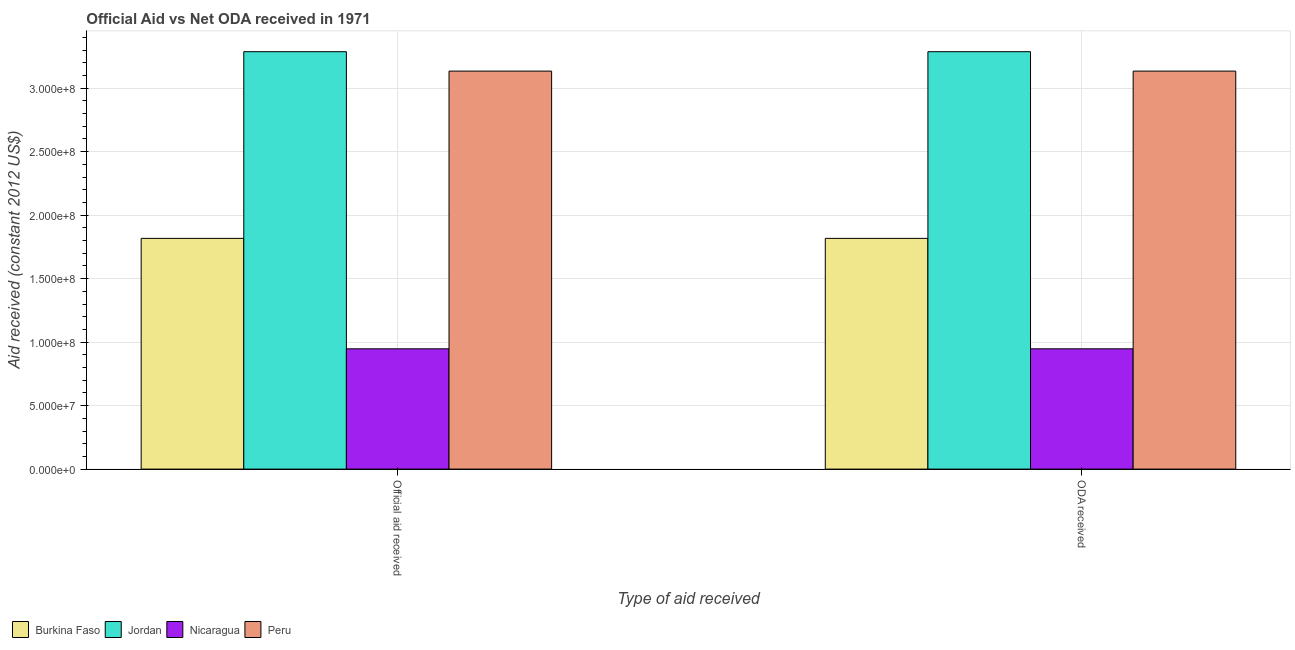How many bars are there on the 1st tick from the left?
Offer a terse response. 4. How many bars are there on the 2nd tick from the right?
Your answer should be very brief. 4. What is the label of the 2nd group of bars from the left?
Ensure brevity in your answer.  ODA received. What is the oda received in Jordan?
Give a very brief answer. 3.29e+08. Across all countries, what is the maximum oda received?
Your response must be concise. 3.29e+08. Across all countries, what is the minimum oda received?
Make the answer very short. 9.47e+07. In which country was the official aid received maximum?
Offer a terse response. Jordan. In which country was the official aid received minimum?
Keep it short and to the point. Nicaragua. What is the total oda received in the graph?
Ensure brevity in your answer.  9.19e+08. What is the difference between the official aid received in Burkina Faso and that in Nicaragua?
Give a very brief answer. 8.70e+07. What is the difference between the oda received in Burkina Faso and the official aid received in Nicaragua?
Make the answer very short. 8.70e+07. What is the average official aid received per country?
Your answer should be very brief. 2.30e+08. What is the difference between the oda received and official aid received in Jordan?
Provide a short and direct response. 0. What is the ratio of the official aid received in Peru to that in Jordan?
Your response must be concise. 0.95. In how many countries, is the oda received greater than the average oda received taken over all countries?
Provide a short and direct response. 2. What does the 2nd bar from the left in ODA received represents?
Provide a succinct answer. Jordan. What does the 3rd bar from the right in ODA received represents?
Ensure brevity in your answer.  Jordan. How many countries are there in the graph?
Ensure brevity in your answer.  4. Are the values on the major ticks of Y-axis written in scientific E-notation?
Offer a very short reply. Yes. Where does the legend appear in the graph?
Keep it short and to the point. Bottom left. How are the legend labels stacked?
Provide a short and direct response. Horizontal. What is the title of the graph?
Give a very brief answer. Official Aid vs Net ODA received in 1971 . Does "Latin America(developing only)" appear as one of the legend labels in the graph?
Ensure brevity in your answer.  No. What is the label or title of the X-axis?
Keep it short and to the point. Type of aid received. What is the label or title of the Y-axis?
Your answer should be compact. Aid received (constant 2012 US$). What is the Aid received (constant 2012 US$) of Burkina Faso in Official aid received?
Offer a terse response. 1.82e+08. What is the Aid received (constant 2012 US$) of Jordan in Official aid received?
Provide a short and direct response. 3.29e+08. What is the Aid received (constant 2012 US$) in Nicaragua in Official aid received?
Offer a terse response. 9.47e+07. What is the Aid received (constant 2012 US$) of Peru in Official aid received?
Your answer should be compact. 3.13e+08. What is the Aid received (constant 2012 US$) in Burkina Faso in ODA received?
Provide a succinct answer. 1.82e+08. What is the Aid received (constant 2012 US$) of Jordan in ODA received?
Make the answer very short. 3.29e+08. What is the Aid received (constant 2012 US$) of Nicaragua in ODA received?
Your answer should be very brief. 9.47e+07. What is the Aid received (constant 2012 US$) of Peru in ODA received?
Ensure brevity in your answer.  3.13e+08. Across all Type of aid received, what is the maximum Aid received (constant 2012 US$) of Burkina Faso?
Offer a very short reply. 1.82e+08. Across all Type of aid received, what is the maximum Aid received (constant 2012 US$) in Jordan?
Your response must be concise. 3.29e+08. Across all Type of aid received, what is the maximum Aid received (constant 2012 US$) of Nicaragua?
Give a very brief answer. 9.47e+07. Across all Type of aid received, what is the maximum Aid received (constant 2012 US$) in Peru?
Provide a succinct answer. 3.13e+08. Across all Type of aid received, what is the minimum Aid received (constant 2012 US$) in Burkina Faso?
Offer a very short reply. 1.82e+08. Across all Type of aid received, what is the minimum Aid received (constant 2012 US$) in Jordan?
Offer a very short reply. 3.29e+08. Across all Type of aid received, what is the minimum Aid received (constant 2012 US$) of Nicaragua?
Offer a terse response. 9.47e+07. Across all Type of aid received, what is the minimum Aid received (constant 2012 US$) of Peru?
Give a very brief answer. 3.13e+08. What is the total Aid received (constant 2012 US$) in Burkina Faso in the graph?
Your answer should be very brief. 3.63e+08. What is the total Aid received (constant 2012 US$) in Jordan in the graph?
Your answer should be very brief. 6.57e+08. What is the total Aid received (constant 2012 US$) in Nicaragua in the graph?
Your answer should be very brief. 1.89e+08. What is the total Aid received (constant 2012 US$) in Peru in the graph?
Offer a very short reply. 6.27e+08. What is the difference between the Aid received (constant 2012 US$) of Jordan in Official aid received and that in ODA received?
Keep it short and to the point. 0. What is the difference between the Aid received (constant 2012 US$) of Peru in Official aid received and that in ODA received?
Offer a very short reply. 0. What is the difference between the Aid received (constant 2012 US$) in Burkina Faso in Official aid received and the Aid received (constant 2012 US$) in Jordan in ODA received?
Offer a very short reply. -1.47e+08. What is the difference between the Aid received (constant 2012 US$) of Burkina Faso in Official aid received and the Aid received (constant 2012 US$) of Nicaragua in ODA received?
Your answer should be very brief. 8.70e+07. What is the difference between the Aid received (constant 2012 US$) of Burkina Faso in Official aid received and the Aid received (constant 2012 US$) of Peru in ODA received?
Offer a very short reply. -1.32e+08. What is the difference between the Aid received (constant 2012 US$) of Jordan in Official aid received and the Aid received (constant 2012 US$) of Nicaragua in ODA received?
Your answer should be compact. 2.34e+08. What is the difference between the Aid received (constant 2012 US$) of Jordan in Official aid received and the Aid received (constant 2012 US$) of Peru in ODA received?
Make the answer very short. 1.53e+07. What is the difference between the Aid received (constant 2012 US$) of Nicaragua in Official aid received and the Aid received (constant 2012 US$) of Peru in ODA received?
Provide a succinct answer. -2.19e+08. What is the average Aid received (constant 2012 US$) in Burkina Faso per Type of aid received?
Offer a terse response. 1.82e+08. What is the average Aid received (constant 2012 US$) of Jordan per Type of aid received?
Give a very brief answer. 3.29e+08. What is the average Aid received (constant 2012 US$) in Nicaragua per Type of aid received?
Provide a succinct answer. 9.47e+07. What is the average Aid received (constant 2012 US$) in Peru per Type of aid received?
Ensure brevity in your answer.  3.13e+08. What is the difference between the Aid received (constant 2012 US$) of Burkina Faso and Aid received (constant 2012 US$) of Jordan in Official aid received?
Provide a short and direct response. -1.47e+08. What is the difference between the Aid received (constant 2012 US$) of Burkina Faso and Aid received (constant 2012 US$) of Nicaragua in Official aid received?
Ensure brevity in your answer.  8.70e+07. What is the difference between the Aid received (constant 2012 US$) of Burkina Faso and Aid received (constant 2012 US$) of Peru in Official aid received?
Offer a terse response. -1.32e+08. What is the difference between the Aid received (constant 2012 US$) of Jordan and Aid received (constant 2012 US$) of Nicaragua in Official aid received?
Keep it short and to the point. 2.34e+08. What is the difference between the Aid received (constant 2012 US$) of Jordan and Aid received (constant 2012 US$) of Peru in Official aid received?
Provide a succinct answer. 1.53e+07. What is the difference between the Aid received (constant 2012 US$) in Nicaragua and Aid received (constant 2012 US$) in Peru in Official aid received?
Offer a terse response. -2.19e+08. What is the difference between the Aid received (constant 2012 US$) of Burkina Faso and Aid received (constant 2012 US$) of Jordan in ODA received?
Your answer should be very brief. -1.47e+08. What is the difference between the Aid received (constant 2012 US$) in Burkina Faso and Aid received (constant 2012 US$) in Nicaragua in ODA received?
Your response must be concise. 8.70e+07. What is the difference between the Aid received (constant 2012 US$) in Burkina Faso and Aid received (constant 2012 US$) in Peru in ODA received?
Ensure brevity in your answer.  -1.32e+08. What is the difference between the Aid received (constant 2012 US$) in Jordan and Aid received (constant 2012 US$) in Nicaragua in ODA received?
Your answer should be very brief. 2.34e+08. What is the difference between the Aid received (constant 2012 US$) of Jordan and Aid received (constant 2012 US$) of Peru in ODA received?
Your answer should be compact. 1.53e+07. What is the difference between the Aid received (constant 2012 US$) of Nicaragua and Aid received (constant 2012 US$) of Peru in ODA received?
Keep it short and to the point. -2.19e+08. What is the ratio of the Aid received (constant 2012 US$) of Burkina Faso in Official aid received to that in ODA received?
Give a very brief answer. 1. What is the ratio of the Aid received (constant 2012 US$) in Peru in Official aid received to that in ODA received?
Your answer should be very brief. 1. What is the difference between the highest and the second highest Aid received (constant 2012 US$) in Burkina Faso?
Ensure brevity in your answer.  0. What is the difference between the highest and the second highest Aid received (constant 2012 US$) in Jordan?
Your answer should be very brief. 0. What is the difference between the highest and the second highest Aid received (constant 2012 US$) of Nicaragua?
Offer a very short reply. 0. What is the difference between the highest and the lowest Aid received (constant 2012 US$) in Burkina Faso?
Your answer should be very brief. 0. What is the difference between the highest and the lowest Aid received (constant 2012 US$) in Jordan?
Ensure brevity in your answer.  0. What is the difference between the highest and the lowest Aid received (constant 2012 US$) of Peru?
Offer a terse response. 0. 